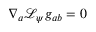<formula> <loc_0><loc_0><loc_500><loc_500>\nabla _ { a } \mathcal { L } _ { \psi } g _ { a b } = 0</formula> 